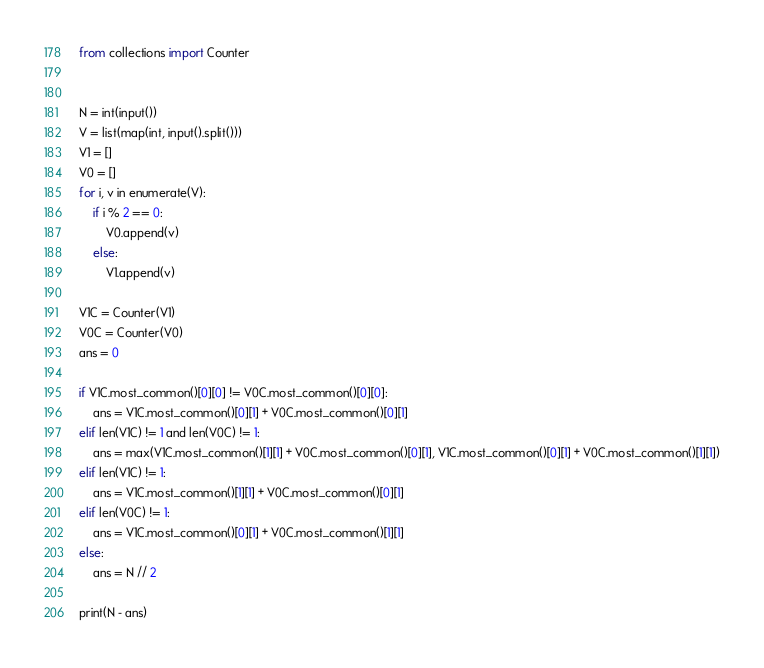<code> <loc_0><loc_0><loc_500><loc_500><_Python_>from collections import Counter


N = int(input())
V = list(map(int, input().split()))
V1 = []
V0 = []
for i, v in enumerate(V):
    if i % 2 == 0:
        V0.append(v)
    else:
        V1.append(v)

V1C = Counter(V1)
V0C = Counter(V0)
ans = 0

if V1C.most_common()[0][0] != V0C.most_common()[0][0]:
    ans = V1C.most_common()[0][1] + V0C.most_common()[0][1]
elif len(V1C) != 1 and len(V0C) != 1:
    ans = max(V1C.most_common()[1][1] + V0C.most_common()[0][1], V1C.most_common()[0][1] + V0C.most_common()[1][1])
elif len(V1C) != 1:
    ans = V1C.most_common()[1][1] + V0C.most_common()[0][1]
elif len(V0C) != 1:
    ans = V1C.most_common()[0][1] + V0C.most_common()[1][1]
else:
    ans = N // 2

print(N - ans)

</code> 